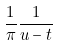<formula> <loc_0><loc_0><loc_500><loc_500>\frac { 1 } { \pi } \frac { 1 } { u - t }</formula> 